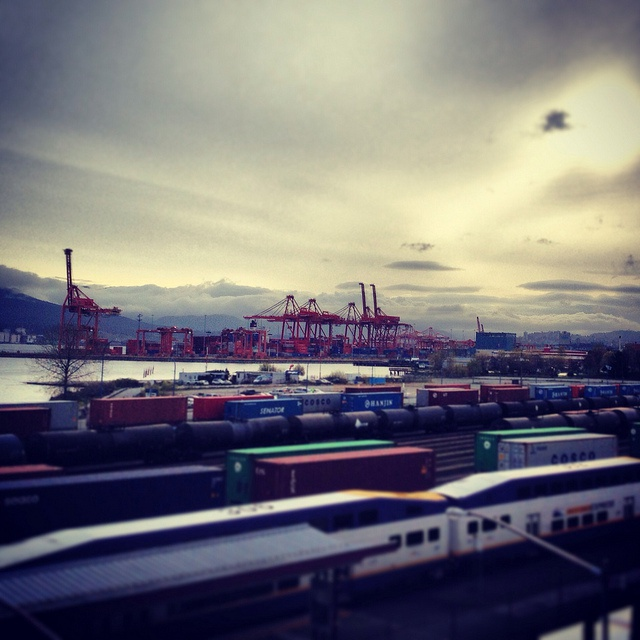Describe the objects in this image and their specific colors. I can see train in darkblue, navy, and gray tones, train in darkblue, navy, gray, and darkgray tones, train in darkblue, navy, purple, and gray tones, train in darkblue, navy, and purple tones, and train in darkblue, navy, brown, purple, and salmon tones in this image. 